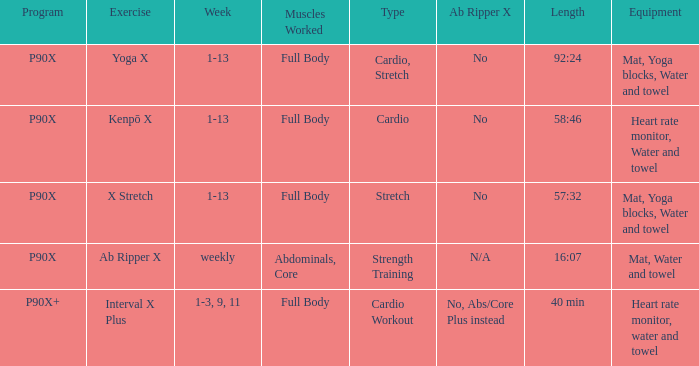What is the ab ripper x when exercise is x stretch? No. 